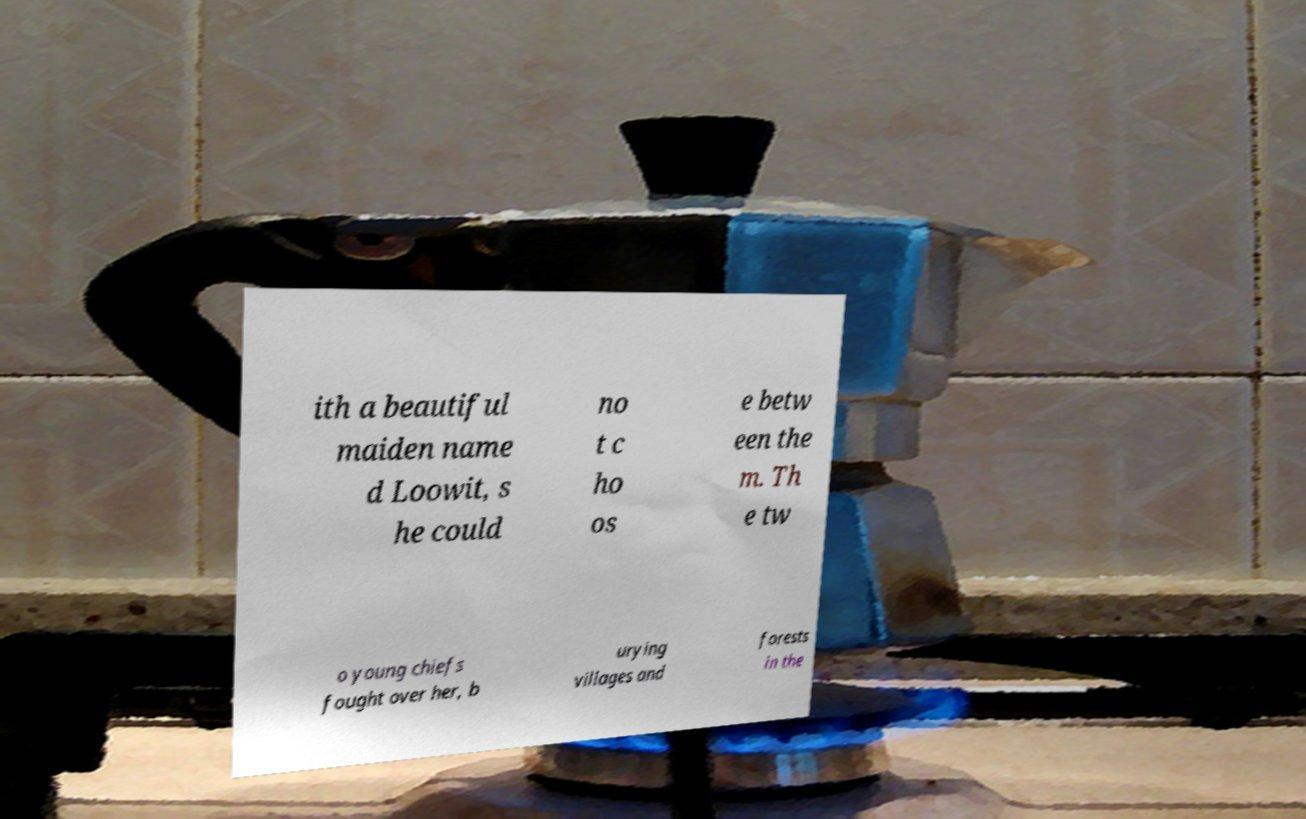Please read and relay the text visible in this image. What does it say? ith a beautiful maiden name d Loowit, s he could no t c ho os e betw een the m. Th e tw o young chiefs fought over her, b urying villages and forests in the 